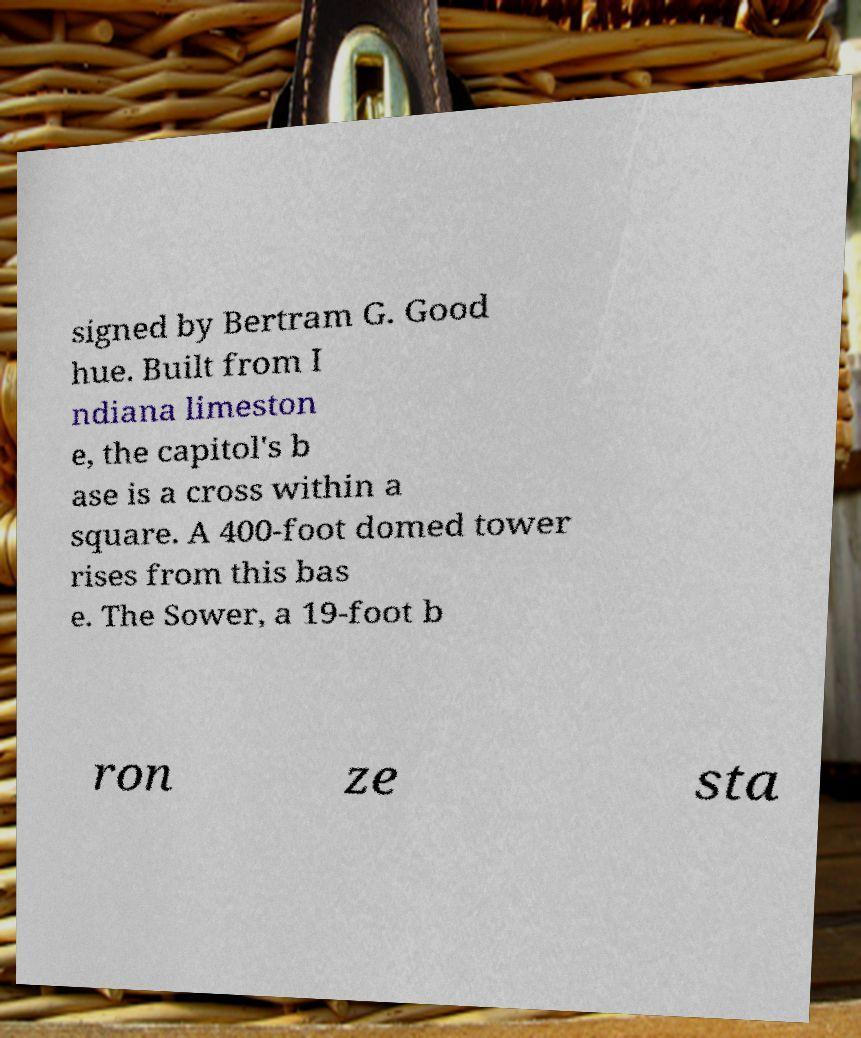Can you read and provide the text displayed in the image?This photo seems to have some interesting text. Can you extract and type it out for me? signed by Bertram G. Good hue. Built from I ndiana limeston e, the capitol's b ase is a cross within a square. A 400-foot domed tower rises from this bas e. The Sower, a 19-foot b ron ze sta 